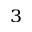Convert formula to latex. <formula><loc_0><loc_0><loc_500><loc_500>^ { 3 }</formula> 